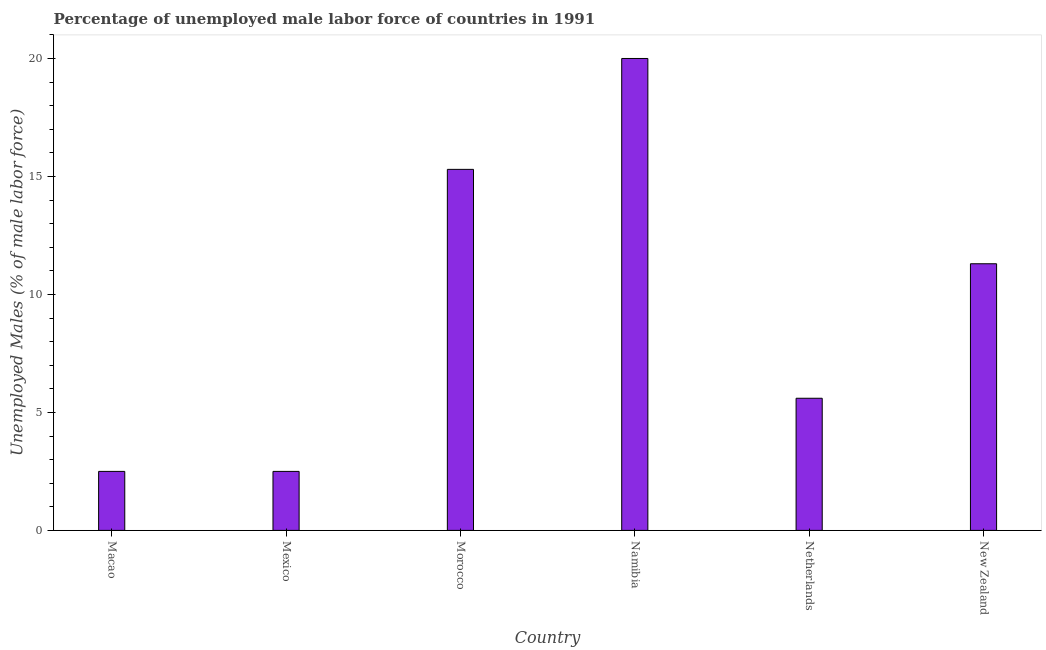Does the graph contain any zero values?
Provide a succinct answer. No. What is the title of the graph?
Ensure brevity in your answer.  Percentage of unemployed male labor force of countries in 1991. What is the label or title of the Y-axis?
Your answer should be compact. Unemployed Males (% of male labor force). Across all countries, what is the minimum total unemployed male labour force?
Provide a succinct answer. 2.5. In which country was the total unemployed male labour force maximum?
Your response must be concise. Namibia. In which country was the total unemployed male labour force minimum?
Keep it short and to the point. Macao. What is the sum of the total unemployed male labour force?
Provide a succinct answer. 57.2. What is the average total unemployed male labour force per country?
Your response must be concise. 9.53. What is the median total unemployed male labour force?
Provide a short and direct response. 8.45. In how many countries, is the total unemployed male labour force greater than 8 %?
Give a very brief answer. 3. Is the total unemployed male labour force in Macao less than that in Namibia?
Your response must be concise. Yes. Is the difference between the total unemployed male labour force in Mexico and Netherlands greater than the difference between any two countries?
Ensure brevity in your answer.  No. In how many countries, is the total unemployed male labour force greater than the average total unemployed male labour force taken over all countries?
Your answer should be compact. 3. How many bars are there?
Offer a terse response. 6. Are all the bars in the graph horizontal?
Keep it short and to the point. No. What is the Unemployed Males (% of male labor force) in Morocco?
Offer a terse response. 15.3. What is the Unemployed Males (% of male labor force) in Netherlands?
Make the answer very short. 5.6. What is the Unemployed Males (% of male labor force) of New Zealand?
Offer a very short reply. 11.3. What is the difference between the Unemployed Males (% of male labor force) in Macao and Morocco?
Make the answer very short. -12.8. What is the difference between the Unemployed Males (% of male labor force) in Macao and Namibia?
Offer a terse response. -17.5. What is the difference between the Unemployed Males (% of male labor force) in Macao and Netherlands?
Offer a very short reply. -3.1. What is the difference between the Unemployed Males (% of male labor force) in Mexico and Namibia?
Provide a short and direct response. -17.5. What is the difference between the Unemployed Males (% of male labor force) in Mexico and New Zealand?
Offer a very short reply. -8.8. What is the difference between the Unemployed Males (% of male labor force) in Morocco and Namibia?
Provide a short and direct response. -4.7. What is the difference between the Unemployed Males (% of male labor force) in Morocco and New Zealand?
Keep it short and to the point. 4. What is the difference between the Unemployed Males (% of male labor force) in Netherlands and New Zealand?
Your response must be concise. -5.7. What is the ratio of the Unemployed Males (% of male labor force) in Macao to that in Morocco?
Give a very brief answer. 0.16. What is the ratio of the Unemployed Males (% of male labor force) in Macao to that in Netherlands?
Provide a short and direct response. 0.45. What is the ratio of the Unemployed Males (% of male labor force) in Macao to that in New Zealand?
Make the answer very short. 0.22. What is the ratio of the Unemployed Males (% of male labor force) in Mexico to that in Morocco?
Your answer should be compact. 0.16. What is the ratio of the Unemployed Males (% of male labor force) in Mexico to that in Namibia?
Keep it short and to the point. 0.12. What is the ratio of the Unemployed Males (% of male labor force) in Mexico to that in Netherlands?
Provide a short and direct response. 0.45. What is the ratio of the Unemployed Males (% of male labor force) in Mexico to that in New Zealand?
Your response must be concise. 0.22. What is the ratio of the Unemployed Males (% of male labor force) in Morocco to that in Namibia?
Your answer should be compact. 0.77. What is the ratio of the Unemployed Males (% of male labor force) in Morocco to that in Netherlands?
Give a very brief answer. 2.73. What is the ratio of the Unemployed Males (% of male labor force) in Morocco to that in New Zealand?
Your answer should be very brief. 1.35. What is the ratio of the Unemployed Males (% of male labor force) in Namibia to that in Netherlands?
Make the answer very short. 3.57. What is the ratio of the Unemployed Males (% of male labor force) in Namibia to that in New Zealand?
Give a very brief answer. 1.77. What is the ratio of the Unemployed Males (% of male labor force) in Netherlands to that in New Zealand?
Give a very brief answer. 0.5. 